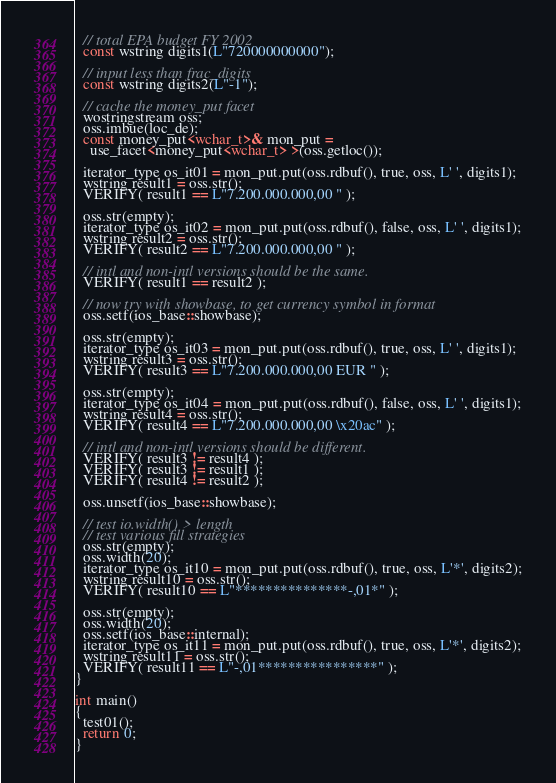Convert code to text. <code><loc_0><loc_0><loc_500><loc_500><_C++_>
  // total EPA budget FY 2002
  const wstring digits1(L"720000000000");

  // input less than frac_digits
  const wstring digits2(L"-1");
  
  // cache the money_put facet
  wostringstream oss;
  oss.imbue(loc_de);
  const money_put<wchar_t>& mon_put =
    use_facet<money_put<wchar_t> >(oss.getloc()); 

  iterator_type os_it01 = mon_put.put(oss.rdbuf(), true, oss, L' ', digits1);
  wstring result1 = oss.str();
  VERIFY( result1 == L"7.200.000.000,00 " );

  oss.str(empty);
  iterator_type os_it02 = mon_put.put(oss.rdbuf(), false, oss, L' ', digits1);
  wstring result2 = oss.str();
  VERIFY( result2 == L"7.200.000.000,00 " );

  // intl and non-intl versions should be the same.
  VERIFY( result1 == result2 );

  // now try with showbase, to get currency symbol in format
  oss.setf(ios_base::showbase);

  oss.str(empty);
  iterator_type os_it03 = mon_put.put(oss.rdbuf(), true, oss, L' ', digits1);
  wstring result3 = oss.str();
  VERIFY( result3 == L"7.200.000.000,00 EUR " );

  oss.str(empty);
  iterator_type os_it04 = mon_put.put(oss.rdbuf(), false, oss, L' ', digits1);
  wstring result4 = oss.str();
  VERIFY( result4 == L"7.200.000.000,00 \x20ac" );

  // intl and non-intl versions should be different.
  VERIFY( result3 != result4 );
  VERIFY( result3 != result1 );
  VERIFY( result4 != result2 );

  oss.unsetf(ios_base::showbase);

  // test io.width() > length
  // test various fill strategies
  oss.str(empty);
  oss.width(20);
  iterator_type os_it10 = mon_put.put(oss.rdbuf(), true, oss, L'*', digits2);
  wstring result10 = oss.str();
  VERIFY( result10 == L"***************-,01*" );

  oss.str(empty);
  oss.width(20);
  oss.setf(ios_base::internal);
  iterator_type os_it11 = mon_put.put(oss.rdbuf(), true, oss, L'*', digits2);
  wstring result11 = oss.str();
  VERIFY( result11 == L"-,01****************" );
}

int main()
{
  test01();
  return 0;
}
</code> 